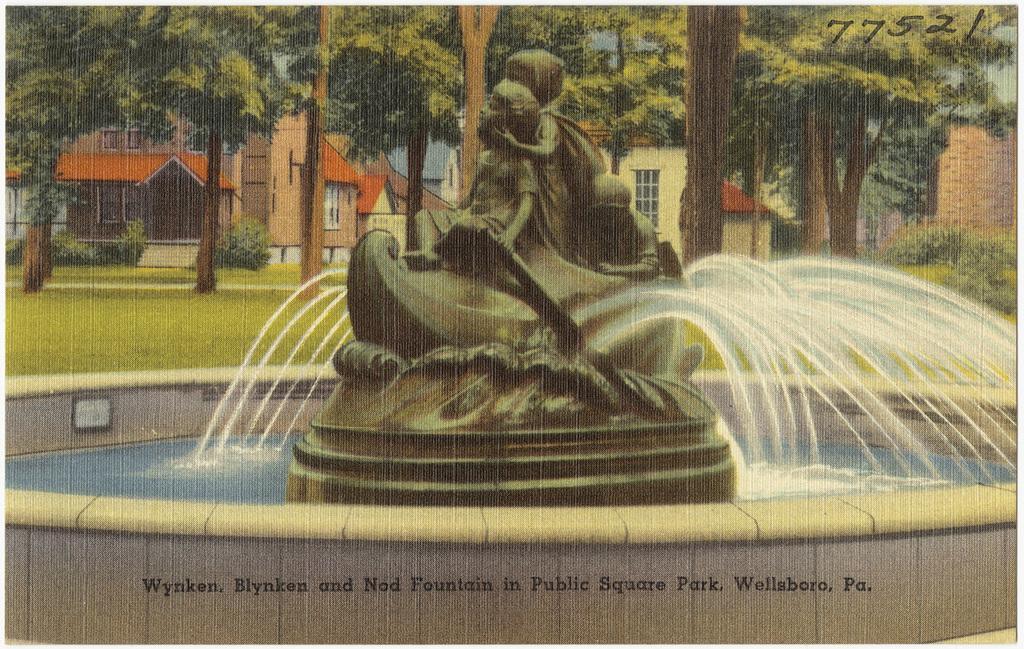Describe this image in one or two sentences. Here we can see a water fountain with status. Background there are houses with windows, plants and trees. Bottom of the image there is a watermark. 